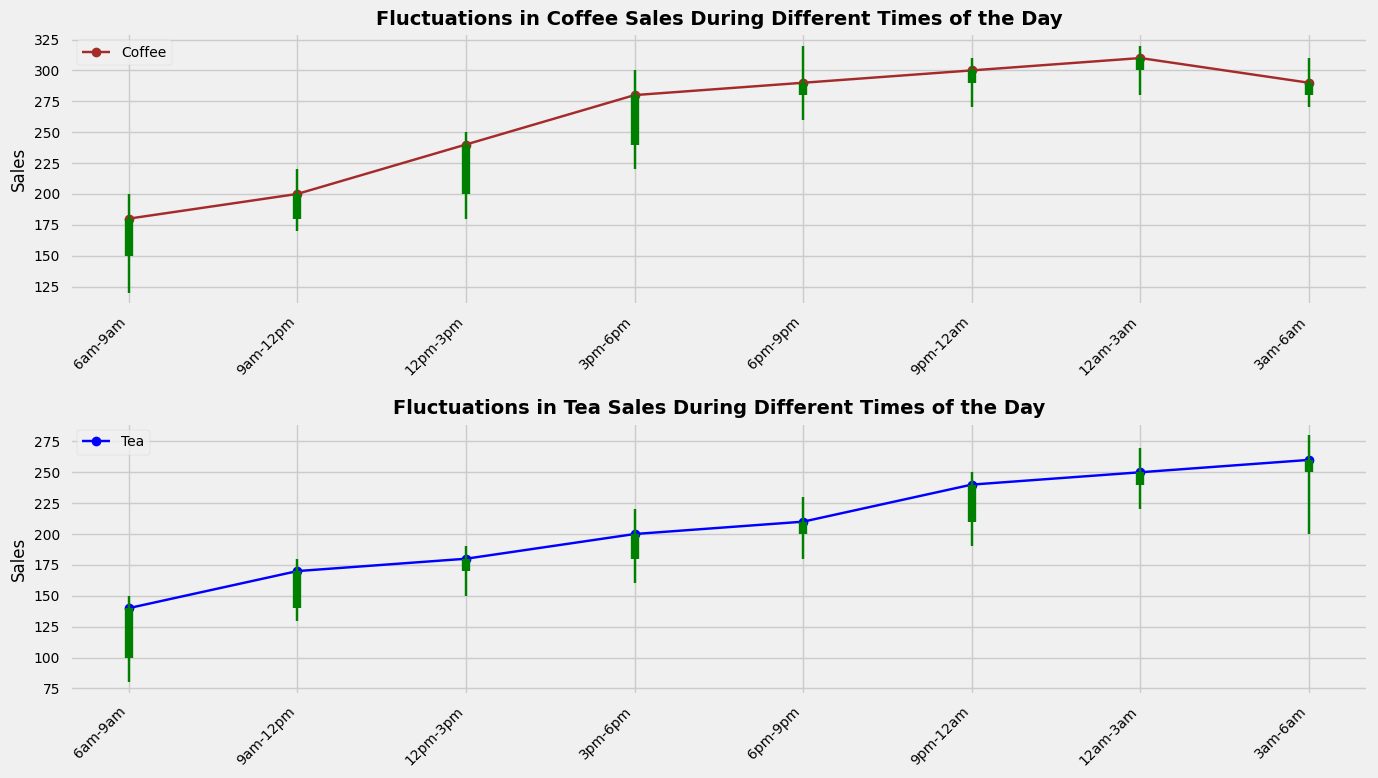What time range has the highest peak in coffee sales? To find the time range with the highest peak in coffee sales, refer to the 'High (Coffee Sales)' values. The highest value is 320, occurring during the time range 6pm-9pm.
Answer: 6pm-9pm How do the opening and closing sales of tea compare during 12pm-3pm? Look at the 'Open (Tea Sales)' and 'Close (Tea Sales)' values for 12pm-3pm. The opening sales are 170, and the closing sales are 180. Therefore, the closing sales are higher.
Answer: Closing sales are higher Which beverage experienced a higher low point during 9pm-12am? Compare the 'Low (Coffee Sales)' and 'Low (Tea Sales)' values for 9pm-12am. Coffee has a low of 270, and tea has a low of 190. Thus, coffee experienced a higher low point.
Answer: Coffee What is the average of the highest sales of tea and coffee during 9pm-12am? The values to consider are 'High (Coffee Sales)' and 'High (Tea Sales)' at 9pm-12am. Coffee has a high of 310, and tea has a high of 250. The average is calculated as (310 + 250) / 2 = 280.
Answer: 280 Is there any time range where both coffee and tea sales close at the highest value of the day? Scan the 'Close (Coffee Sales)' and 'Close (Tea Sales)' columns to find each beverage's highest close value. Coffee's highest close is 310, and tea's highest close is 260. Only 'Tea Sales' closes at its highest during 3am-6am; no time range has both beverages closing at their highest.
Answer: No Which time range shows the greatest difference between the highest and lowest tea sales? Calculate the range for each time slot using 'High (Tea Sales)' and 'Low (Tea Sales)'. The greatest range is (270 - 220 = 50), which occurs during 12am-3am.
Answer: 12am-3am During which time range does coffee have the smallest fluctuation between opening and closing sales? The fluctuation is calculated by finding the absolute difference between 'Open (Coffee Sales)' and 'Close (Coffee Sales)' for each time slot. The smallest fluctuation is (290 - 280 = 10) at 6pm-9pm.
Answer: 6pm-9pm 